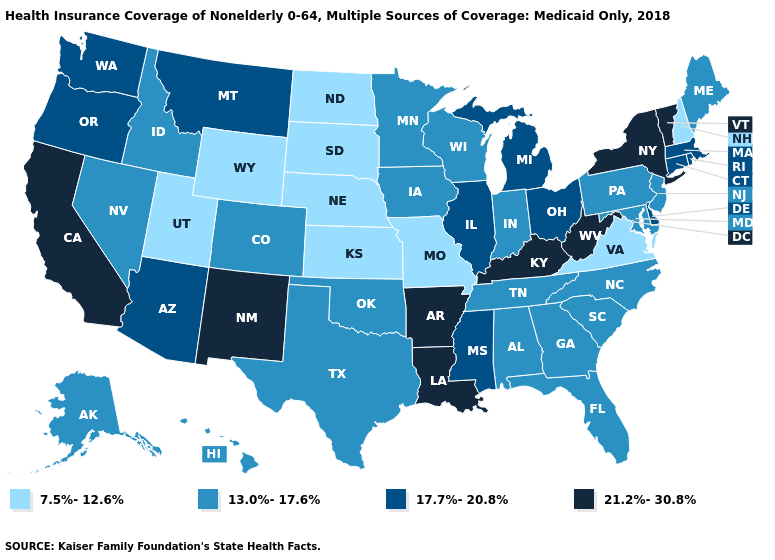What is the value of South Dakota?
Answer briefly. 7.5%-12.6%. What is the value of Tennessee?
Answer briefly. 13.0%-17.6%. Name the states that have a value in the range 21.2%-30.8%?
Answer briefly. Arkansas, California, Kentucky, Louisiana, New Mexico, New York, Vermont, West Virginia. What is the value of Utah?
Write a very short answer. 7.5%-12.6%. What is the value of Wisconsin?
Keep it brief. 13.0%-17.6%. What is the value of Montana?
Short answer required. 17.7%-20.8%. What is the value of Oklahoma?
Be succinct. 13.0%-17.6%. Among the states that border Kentucky , which have the lowest value?
Answer briefly. Missouri, Virginia. Does Tennessee have the highest value in the South?
Quick response, please. No. What is the value of New Hampshire?
Short answer required. 7.5%-12.6%. Which states have the lowest value in the USA?
Concise answer only. Kansas, Missouri, Nebraska, New Hampshire, North Dakota, South Dakota, Utah, Virginia, Wyoming. What is the lowest value in states that border Rhode Island?
Write a very short answer. 17.7%-20.8%. Name the states that have a value in the range 7.5%-12.6%?
Give a very brief answer. Kansas, Missouri, Nebraska, New Hampshire, North Dakota, South Dakota, Utah, Virginia, Wyoming. What is the value of Oregon?
Keep it brief. 17.7%-20.8%. Does Arkansas have a higher value than New York?
Give a very brief answer. No. 